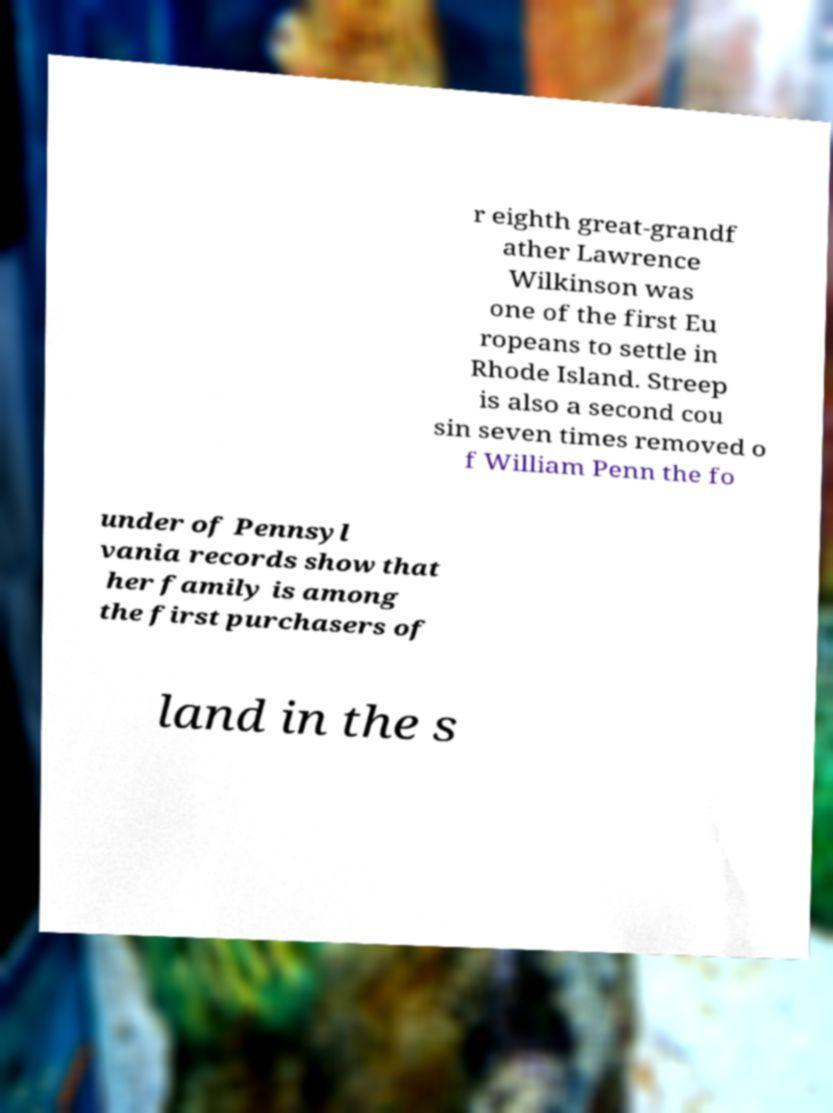Can you accurately transcribe the text from the provided image for me? r eighth great-grandf ather Lawrence Wilkinson was one of the first Eu ropeans to settle in Rhode Island. Streep is also a second cou sin seven times removed o f William Penn the fo under of Pennsyl vania records show that her family is among the first purchasers of land in the s 